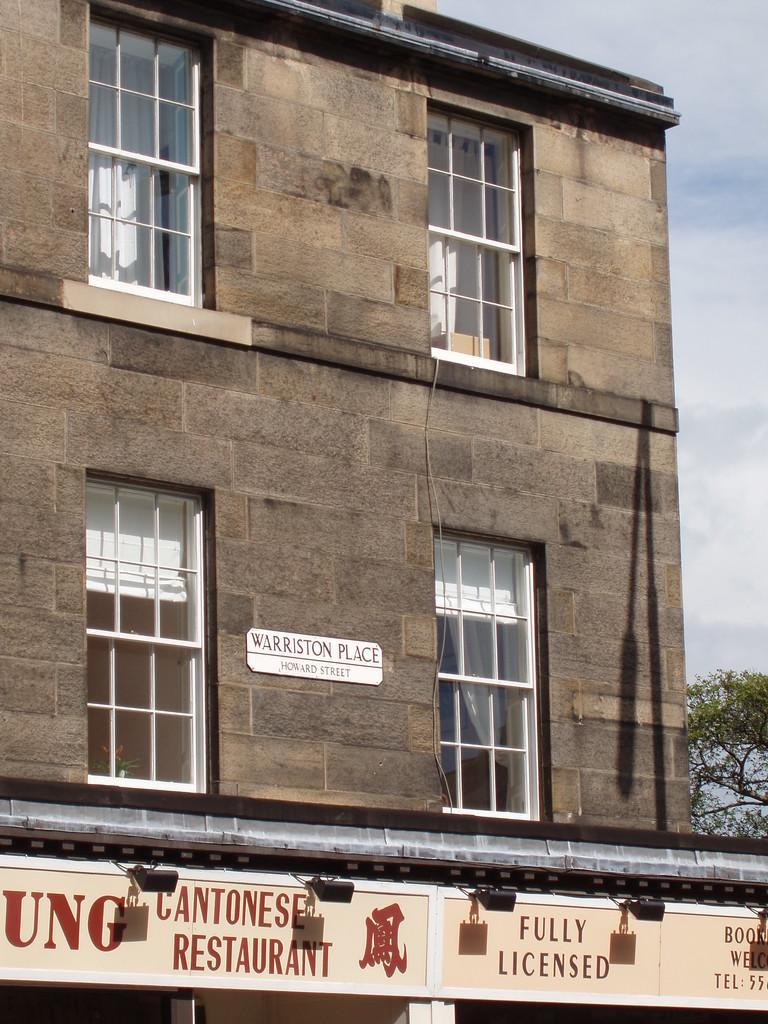How would you summarize this image in a sentence or two? In this picture we can see a brown building with glass windows. In the front bottom side we can see the shop naming board. 